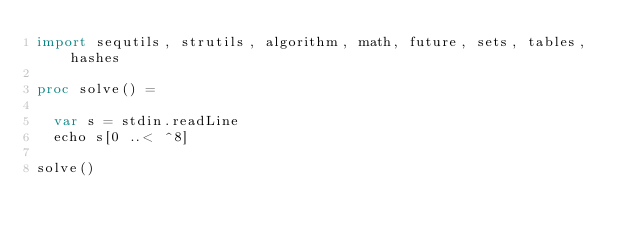Convert code to text. <code><loc_0><loc_0><loc_500><loc_500><_Nim_>import sequtils, strutils, algorithm, math, future, sets, tables, hashes

proc solve() =

  var s = stdin.readLine
  echo s[0 ..< ^8]

solve()</code> 